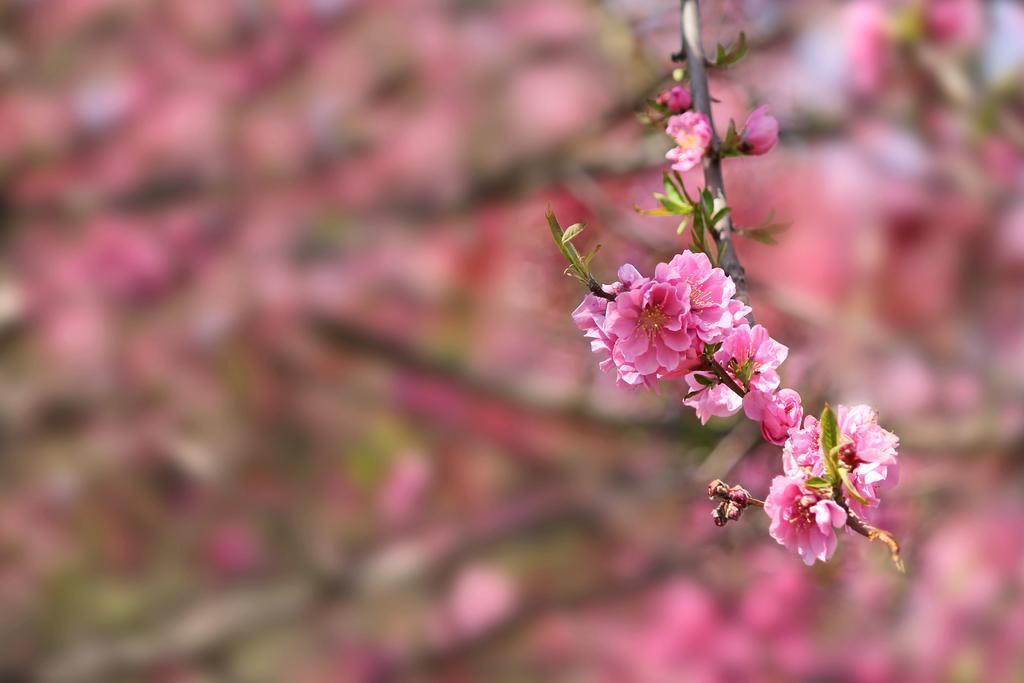How would you summarize this image in a sentence or two? Here we can see a plant with flowers. In the background the image is blur. 